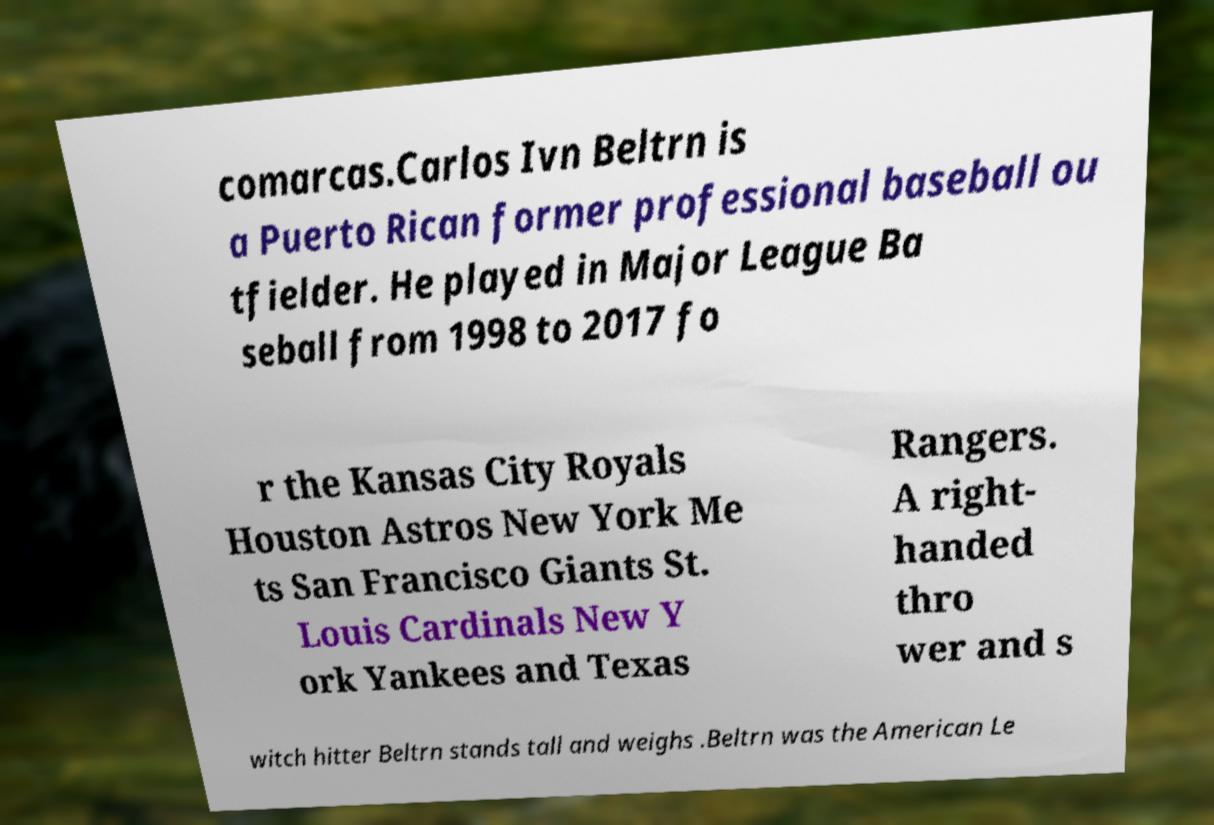Can you accurately transcribe the text from the provided image for me? comarcas.Carlos Ivn Beltrn is a Puerto Rican former professional baseball ou tfielder. He played in Major League Ba seball from 1998 to 2017 fo r the Kansas City Royals Houston Astros New York Me ts San Francisco Giants St. Louis Cardinals New Y ork Yankees and Texas Rangers. A right- handed thro wer and s witch hitter Beltrn stands tall and weighs .Beltrn was the American Le 